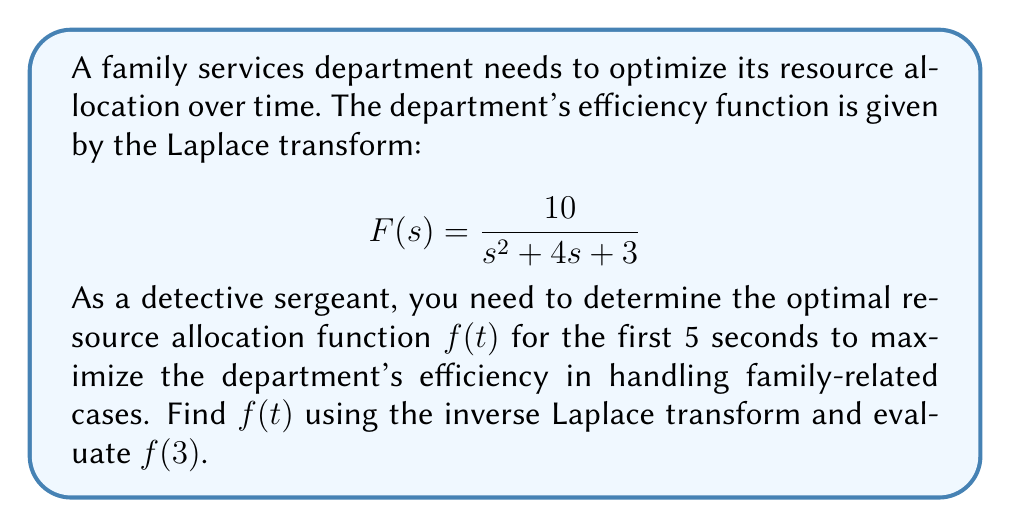Help me with this question. To solve this problem, we need to follow these steps:

1) First, we need to find the inverse Laplace transform of $F(s)$ to get $f(t)$.

2) The given Laplace transform is:

   $$F(s) = \frac{10}{s^2 + 4s + 3}$$

3) This can be rewritten as:

   $$F(s) = \frac{10}{(s+1)(s+3)}$$

4) Using partial fraction decomposition:

   $$\frac{10}{(s+1)(s+3)} = \frac{A}{s+1} + \frac{B}{s+3}$$

5) Solving for A and B:

   $10 = A(s+3) + B(s+1)$
   
   When $s = -1$: $10 = 2A$, so $A = 5$
   When $s = -3$: $10 = -2B$, so $B = -5$

6) Therefore:

   $$F(s) = \frac{5}{s+1} - \frac{5}{s+3}$$

7) Using the inverse Laplace transform:

   $$\mathcal{L}^{-1}\left\{\frac{1}{s+a}\right\} = e^{-at}$$

8) We get:

   $$f(t) = 5e^{-t} - 5e^{-3t}$$

9) To find $f(3)$, we substitute $t = 3$:

   $$f(3) = 5e^{-3} - 5e^{-9}$$

10) Calculating this:

    $$f(3) = 5(0.0498) - 5(0.0001) = 0.2485$$
Answer: The optimal resource allocation function is $f(t) = 5e^{-t} - 5e^{-3t}$, and $f(3) \approx 0.2485$. 